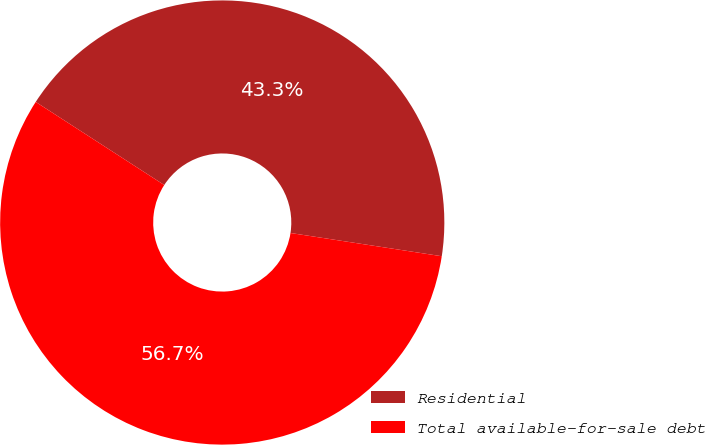<chart> <loc_0><loc_0><loc_500><loc_500><pie_chart><fcel>Residential<fcel>Total available-for-sale debt<nl><fcel>43.29%<fcel>56.71%<nl></chart> 